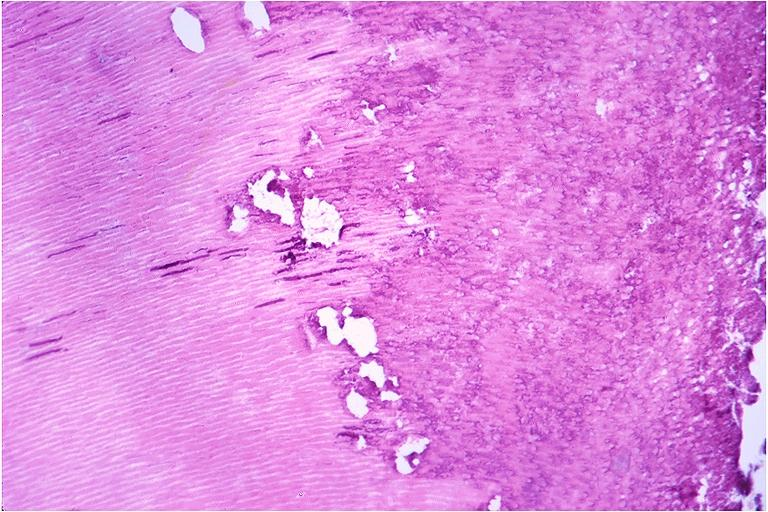what is present?
Answer the question using a single word or phrase. Oral 